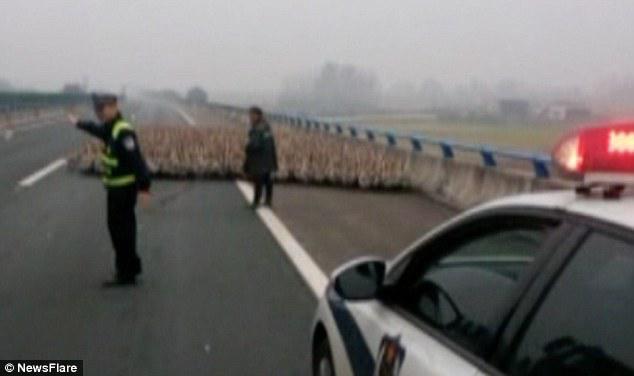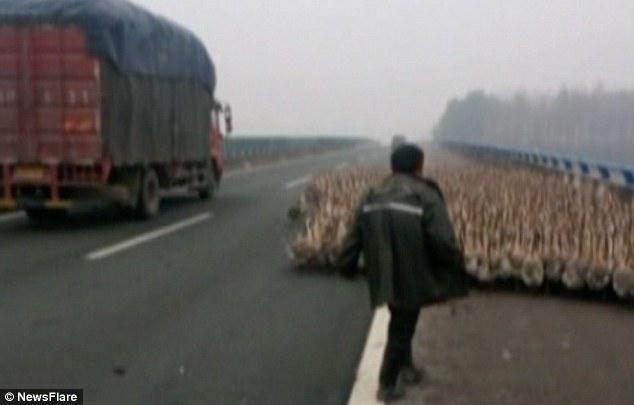The first image is the image on the left, the second image is the image on the right. Considering the images on both sides, is "There is an officer with yellow marked clothing in the street in one of the images." valid? Answer yes or no. Yes. 